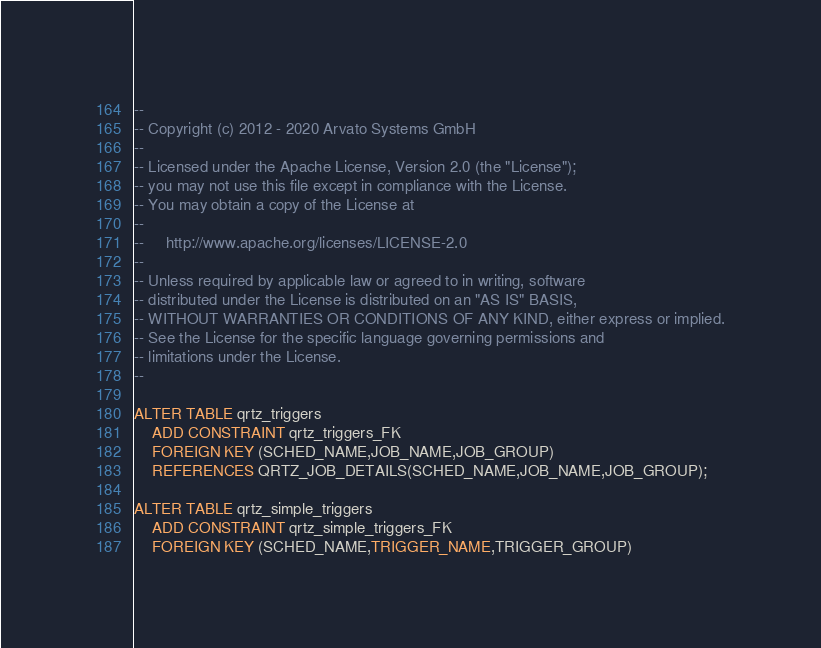Convert code to text. <code><loc_0><loc_0><loc_500><loc_500><_SQL_>--
-- Copyright (c) 2012 - 2020 Arvato Systems GmbH
--
-- Licensed under the Apache License, Version 2.0 (the "License");
-- you may not use this file except in compliance with the License.
-- You may obtain a copy of the License at
--
--     http://www.apache.org/licenses/LICENSE-2.0
--
-- Unless required by applicable law or agreed to in writing, software
-- distributed under the License is distributed on an "AS IS" BASIS,
-- WITHOUT WARRANTIES OR CONDITIONS OF ANY KIND, either express or implied.
-- See the License for the specific language governing permissions and
-- limitations under the License.
--

ALTER TABLE qrtz_triggers
    ADD CONSTRAINT qrtz_triggers_FK
    FOREIGN KEY (SCHED_NAME,JOB_NAME,JOB_GROUP)
    REFERENCES QRTZ_JOB_DETAILS(SCHED_NAME,JOB_NAME,JOB_GROUP);

ALTER TABLE qrtz_simple_triggers
    ADD CONSTRAINT qrtz_simple_triggers_FK
    FOREIGN KEY (SCHED_NAME,TRIGGER_NAME,TRIGGER_GROUP)</code> 